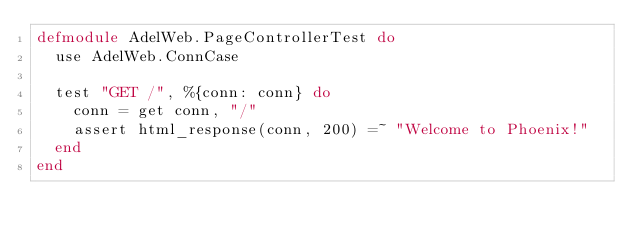<code> <loc_0><loc_0><loc_500><loc_500><_Elixir_>defmodule AdelWeb.PageControllerTest do
  use AdelWeb.ConnCase

  test "GET /", %{conn: conn} do
    conn = get conn, "/"
    assert html_response(conn, 200) =~ "Welcome to Phoenix!"
  end
end
</code> 